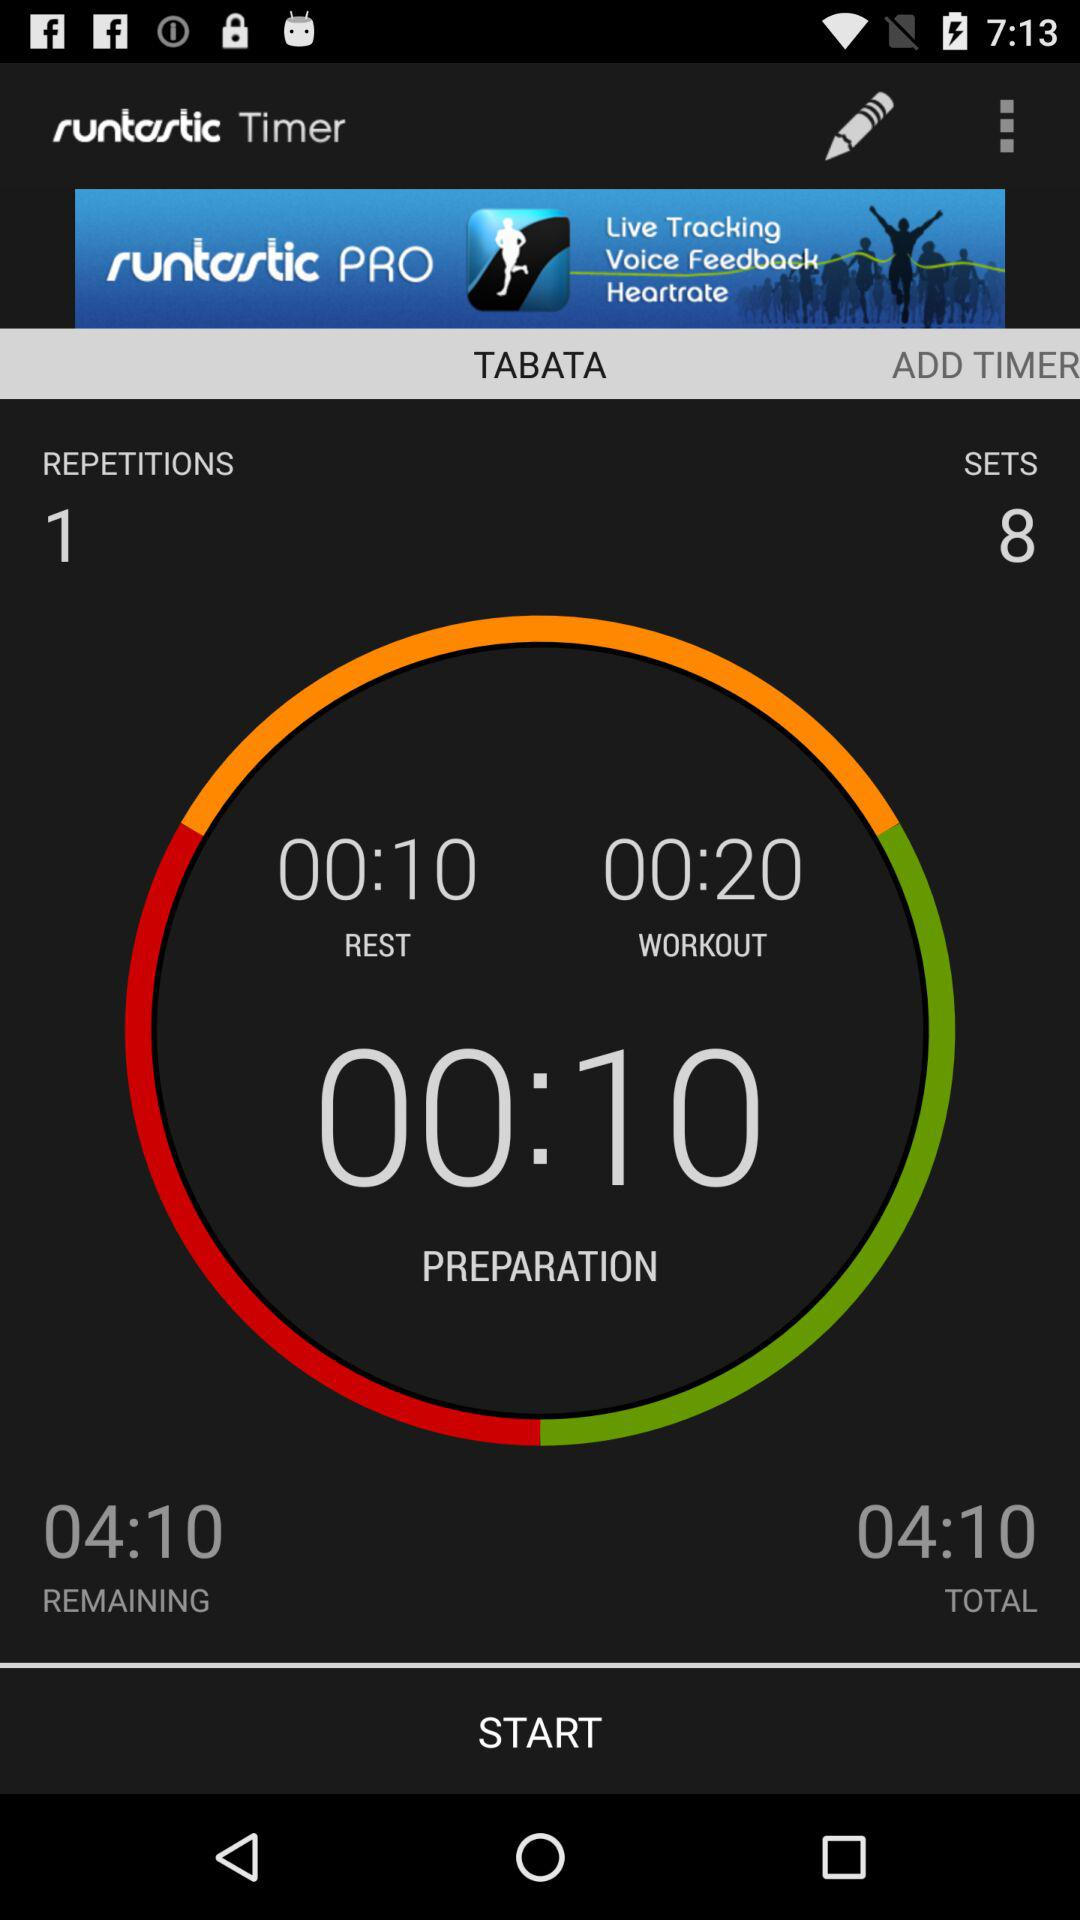What is the number of repetitions? The number of repetitions is 1. 